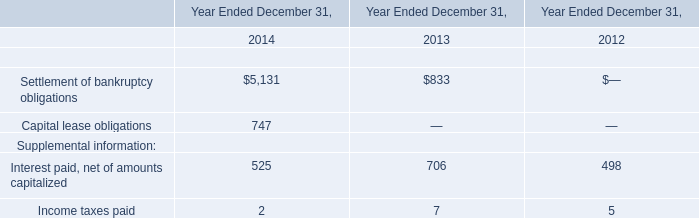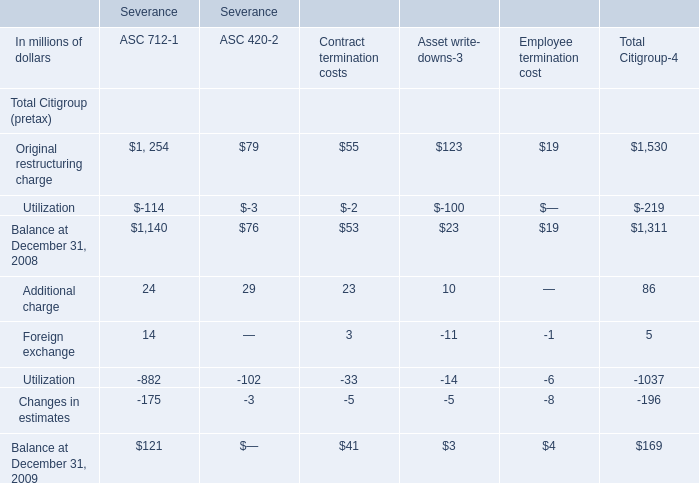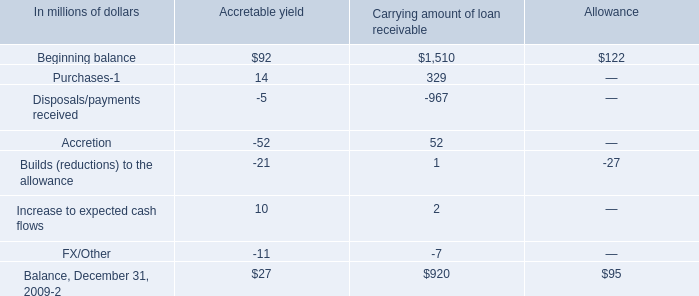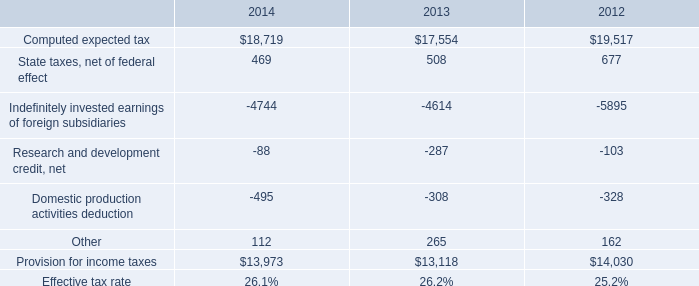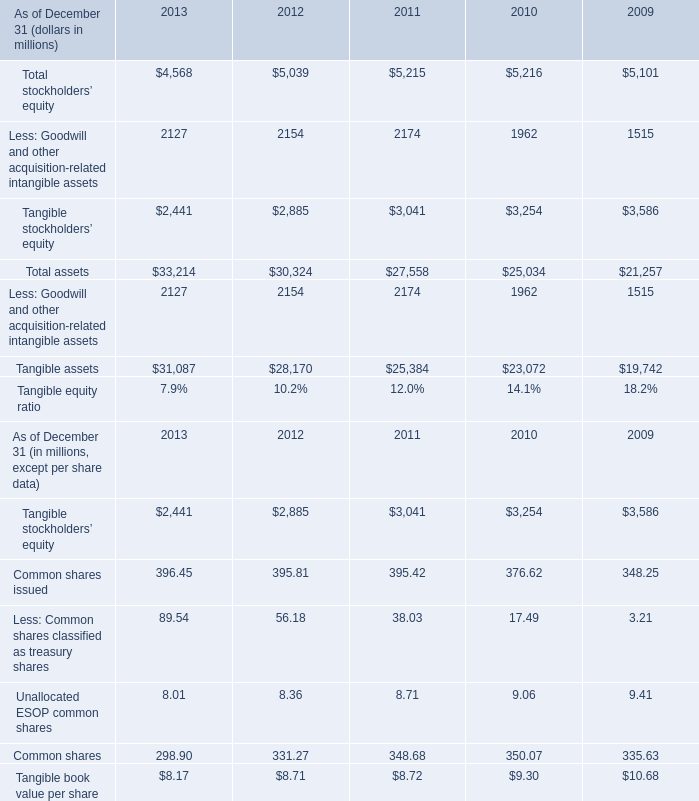What was the average value of the Tangible stockholders’ equity in the years where Less: Goodwill and other acquisition-related intangible assets is positive? (in million) 
Computations: (((((2441 + 2885) + 3041) + 3254) + 3586) / 5)
Answer: 3041.4. 